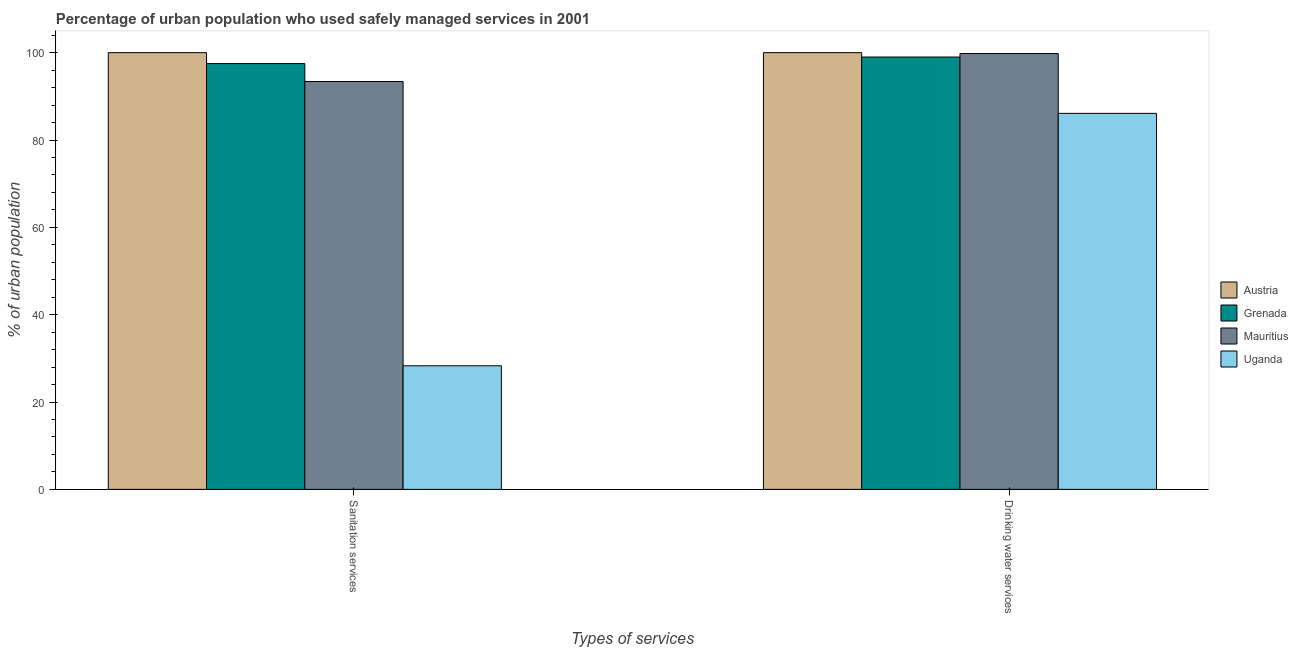How many groups of bars are there?
Make the answer very short. 2. Are the number of bars per tick equal to the number of legend labels?
Give a very brief answer. Yes. How many bars are there on the 2nd tick from the left?
Ensure brevity in your answer.  4. How many bars are there on the 1st tick from the right?
Ensure brevity in your answer.  4. What is the label of the 2nd group of bars from the left?
Provide a short and direct response. Drinking water services. What is the percentage of urban population who used drinking water services in Uganda?
Offer a terse response. 86.1. Across all countries, what is the minimum percentage of urban population who used drinking water services?
Your answer should be compact. 86.1. In which country was the percentage of urban population who used drinking water services minimum?
Your answer should be compact. Uganda. What is the total percentage of urban population who used drinking water services in the graph?
Give a very brief answer. 384.9. What is the difference between the percentage of urban population who used sanitation services in Austria and that in Mauritius?
Ensure brevity in your answer.  6.6. What is the difference between the percentage of urban population who used drinking water services in Austria and the percentage of urban population who used sanitation services in Uganda?
Make the answer very short. 71.7. What is the average percentage of urban population who used sanitation services per country?
Provide a succinct answer. 79.8. What is the difference between the percentage of urban population who used sanitation services and percentage of urban population who used drinking water services in Uganda?
Provide a succinct answer. -57.8. In how many countries, is the percentage of urban population who used sanitation services greater than 16 %?
Give a very brief answer. 4. What is the ratio of the percentage of urban population who used drinking water services in Grenada to that in Uganda?
Offer a terse response. 1.15. Is the percentage of urban population who used sanitation services in Uganda less than that in Mauritius?
Your answer should be very brief. Yes. In how many countries, is the percentage of urban population who used drinking water services greater than the average percentage of urban population who used drinking water services taken over all countries?
Provide a succinct answer. 3. What does the 4th bar from the left in Drinking water services represents?
Offer a very short reply. Uganda. How many bars are there?
Make the answer very short. 8. Are the values on the major ticks of Y-axis written in scientific E-notation?
Provide a succinct answer. No. Where does the legend appear in the graph?
Your answer should be very brief. Center right. How many legend labels are there?
Keep it short and to the point. 4. How are the legend labels stacked?
Ensure brevity in your answer.  Vertical. What is the title of the graph?
Give a very brief answer. Percentage of urban population who used safely managed services in 2001. Does "Sri Lanka" appear as one of the legend labels in the graph?
Your response must be concise. No. What is the label or title of the X-axis?
Give a very brief answer. Types of services. What is the label or title of the Y-axis?
Your answer should be compact. % of urban population. What is the % of urban population in Grenada in Sanitation services?
Give a very brief answer. 97.5. What is the % of urban population of Mauritius in Sanitation services?
Make the answer very short. 93.4. What is the % of urban population in Uganda in Sanitation services?
Your answer should be compact. 28.3. What is the % of urban population in Austria in Drinking water services?
Offer a very short reply. 100. What is the % of urban population in Grenada in Drinking water services?
Keep it short and to the point. 99. What is the % of urban population in Mauritius in Drinking water services?
Provide a short and direct response. 99.8. What is the % of urban population in Uganda in Drinking water services?
Make the answer very short. 86.1. Across all Types of services, what is the maximum % of urban population in Austria?
Ensure brevity in your answer.  100. Across all Types of services, what is the maximum % of urban population in Grenada?
Your answer should be very brief. 99. Across all Types of services, what is the maximum % of urban population of Mauritius?
Your answer should be compact. 99.8. Across all Types of services, what is the maximum % of urban population in Uganda?
Provide a short and direct response. 86.1. Across all Types of services, what is the minimum % of urban population of Austria?
Your answer should be very brief. 100. Across all Types of services, what is the minimum % of urban population of Grenada?
Provide a short and direct response. 97.5. Across all Types of services, what is the minimum % of urban population in Mauritius?
Make the answer very short. 93.4. Across all Types of services, what is the minimum % of urban population in Uganda?
Keep it short and to the point. 28.3. What is the total % of urban population in Austria in the graph?
Keep it short and to the point. 200. What is the total % of urban population of Grenada in the graph?
Ensure brevity in your answer.  196.5. What is the total % of urban population of Mauritius in the graph?
Your answer should be compact. 193.2. What is the total % of urban population in Uganda in the graph?
Your answer should be compact. 114.4. What is the difference between the % of urban population of Austria in Sanitation services and that in Drinking water services?
Make the answer very short. 0. What is the difference between the % of urban population of Uganda in Sanitation services and that in Drinking water services?
Offer a very short reply. -57.8. What is the difference between the % of urban population in Austria in Sanitation services and the % of urban population in Grenada in Drinking water services?
Your answer should be very brief. 1. What is the difference between the % of urban population in Austria in Sanitation services and the % of urban population in Mauritius in Drinking water services?
Give a very brief answer. 0.2. What is the difference between the % of urban population in Grenada in Sanitation services and the % of urban population in Uganda in Drinking water services?
Provide a short and direct response. 11.4. What is the difference between the % of urban population of Mauritius in Sanitation services and the % of urban population of Uganda in Drinking water services?
Your answer should be very brief. 7.3. What is the average % of urban population of Austria per Types of services?
Ensure brevity in your answer.  100. What is the average % of urban population in Grenada per Types of services?
Keep it short and to the point. 98.25. What is the average % of urban population in Mauritius per Types of services?
Provide a short and direct response. 96.6. What is the average % of urban population in Uganda per Types of services?
Give a very brief answer. 57.2. What is the difference between the % of urban population in Austria and % of urban population in Grenada in Sanitation services?
Make the answer very short. 2.5. What is the difference between the % of urban population of Austria and % of urban population of Uganda in Sanitation services?
Your answer should be very brief. 71.7. What is the difference between the % of urban population in Grenada and % of urban population in Uganda in Sanitation services?
Give a very brief answer. 69.2. What is the difference between the % of urban population of Mauritius and % of urban population of Uganda in Sanitation services?
Offer a terse response. 65.1. What is the difference between the % of urban population of Austria and % of urban population of Grenada in Drinking water services?
Provide a succinct answer. 1. What is the difference between the % of urban population of Austria and % of urban population of Mauritius in Drinking water services?
Your answer should be very brief. 0.2. What is the difference between the % of urban population of Mauritius and % of urban population of Uganda in Drinking water services?
Your answer should be compact. 13.7. What is the ratio of the % of urban population in Mauritius in Sanitation services to that in Drinking water services?
Ensure brevity in your answer.  0.94. What is the ratio of the % of urban population in Uganda in Sanitation services to that in Drinking water services?
Make the answer very short. 0.33. What is the difference between the highest and the second highest % of urban population in Austria?
Your answer should be compact. 0. What is the difference between the highest and the second highest % of urban population of Mauritius?
Offer a very short reply. 6.4. What is the difference between the highest and the second highest % of urban population in Uganda?
Ensure brevity in your answer.  57.8. What is the difference between the highest and the lowest % of urban population of Uganda?
Make the answer very short. 57.8. 